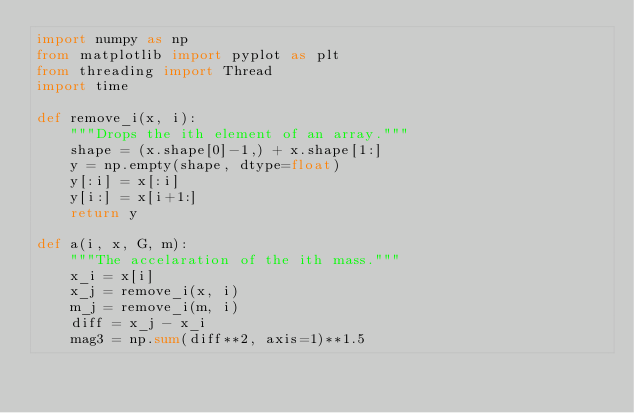<code> <loc_0><loc_0><loc_500><loc_500><_Python_>import numpy as np
from matplotlib import pyplot as plt
from threading import Thread 
import time

def remove_i(x, i):
    """Drops the ith element of an array."""
    shape = (x.shape[0]-1,) + x.shape[1:]
    y = np.empty(shape, dtype=float)
    y[:i] = x[:i]
    y[i:] = x[i+1:]
    return y

def a(i, x, G, m):
    """The accelaration of the ith mass."""
    x_i = x[i]
    x_j = remove_i(x, i)
    m_j = remove_i(m, i)
    diff = x_j - x_i
    mag3 = np.sum(diff**2, axis=1)**1.5</code> 